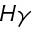Convert formula to latex. <formula><loc_0><loc_0><loc_500><loc_500>H \gamma</formula> 